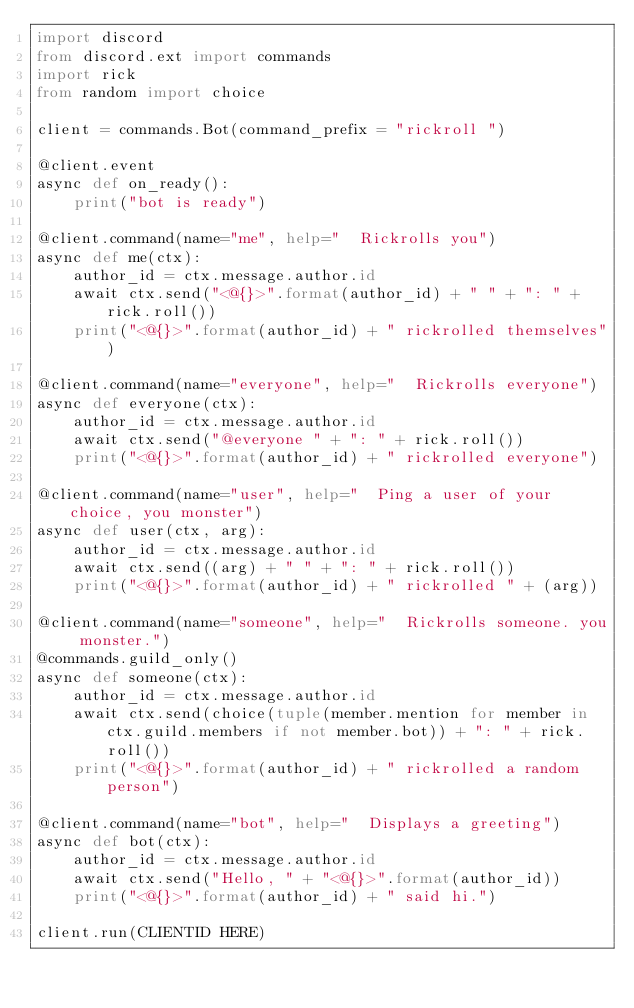Convert code to text. <code><loc_0><loc_0><loc_500><loc_500><_Python_>import discord   
from discord.ext import commands
import rick
from random import choice

client = commands.Bot(command_prefix = "rickroll ")

@client.event
async def on_ready():
    print("bot is ready")

@client.command(name="me", help="  Rickrolls you")
async def me(ctx):
    author_id = ctx.message.author.id
    await ctx.send("<@{}>".format(author_id) + " " + ": " + rick.roll())
    print("<@{}>".format(author_id) + " rickrolled themselves")

@client.command(name="everyone", help="  Rickrolls everyone")
async def everyone(ctx):
    author_id = ctx.message.author.id
    await ctx.send("@everyone " + ": " + rick.roll())
    print("<@{}>".format(author_id) + " rickrolled everyone")

@client.command(name="user", help="  Ping a user of your choice, you monster")
async def user(ctx, arg):
    author_id = ctx.message.author.id
    await ctx.send((arg) + " " + ": " + rick.roll())
    print("<@{}>".format(author_id) + " rickrolled " + (arg))

@client.command(name="someone", help="  Rickrolls someone. you monster.")
@commands.guild_only()
async def someone(ctx):
    author_id = ctx.message.author.id
    await ctx.send(choice(tuple(member.mention for member in ctx.guild.members if not member.bot)) + ": " + rick.roll())
    print("<@{}>".format(author_id) + " rickrolled a random person")

@client.command(name="bot", help="  Displays a greeting")
async def bot(ctx):
    author_id = ctx.message.author.id
    await ctx.send("Hello, " + "<@{}>".format(author_id))
    print("<@{}>".format(author_id) + " said hi.")

client.run(CLIENTID HERE)
</code> 